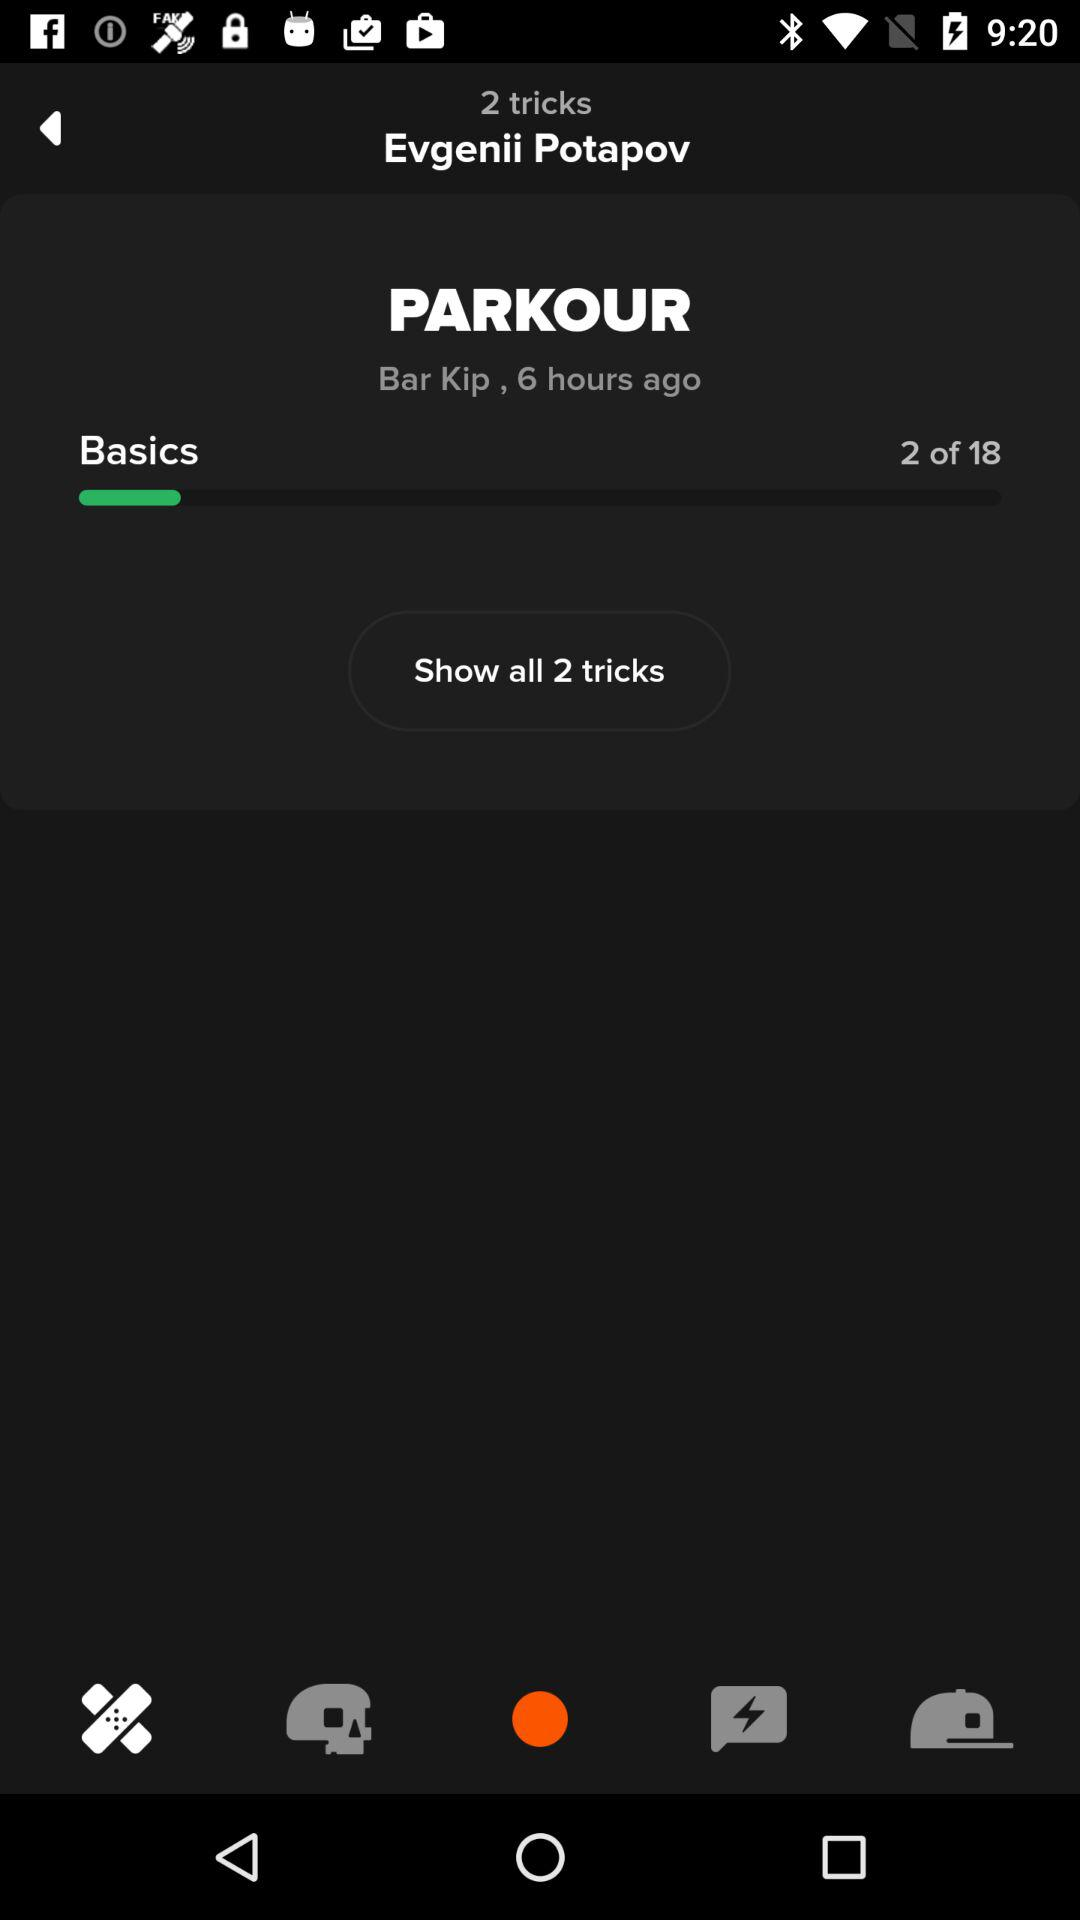How many tricks are there in total?
Answer the question using a single word or phrase. 18 